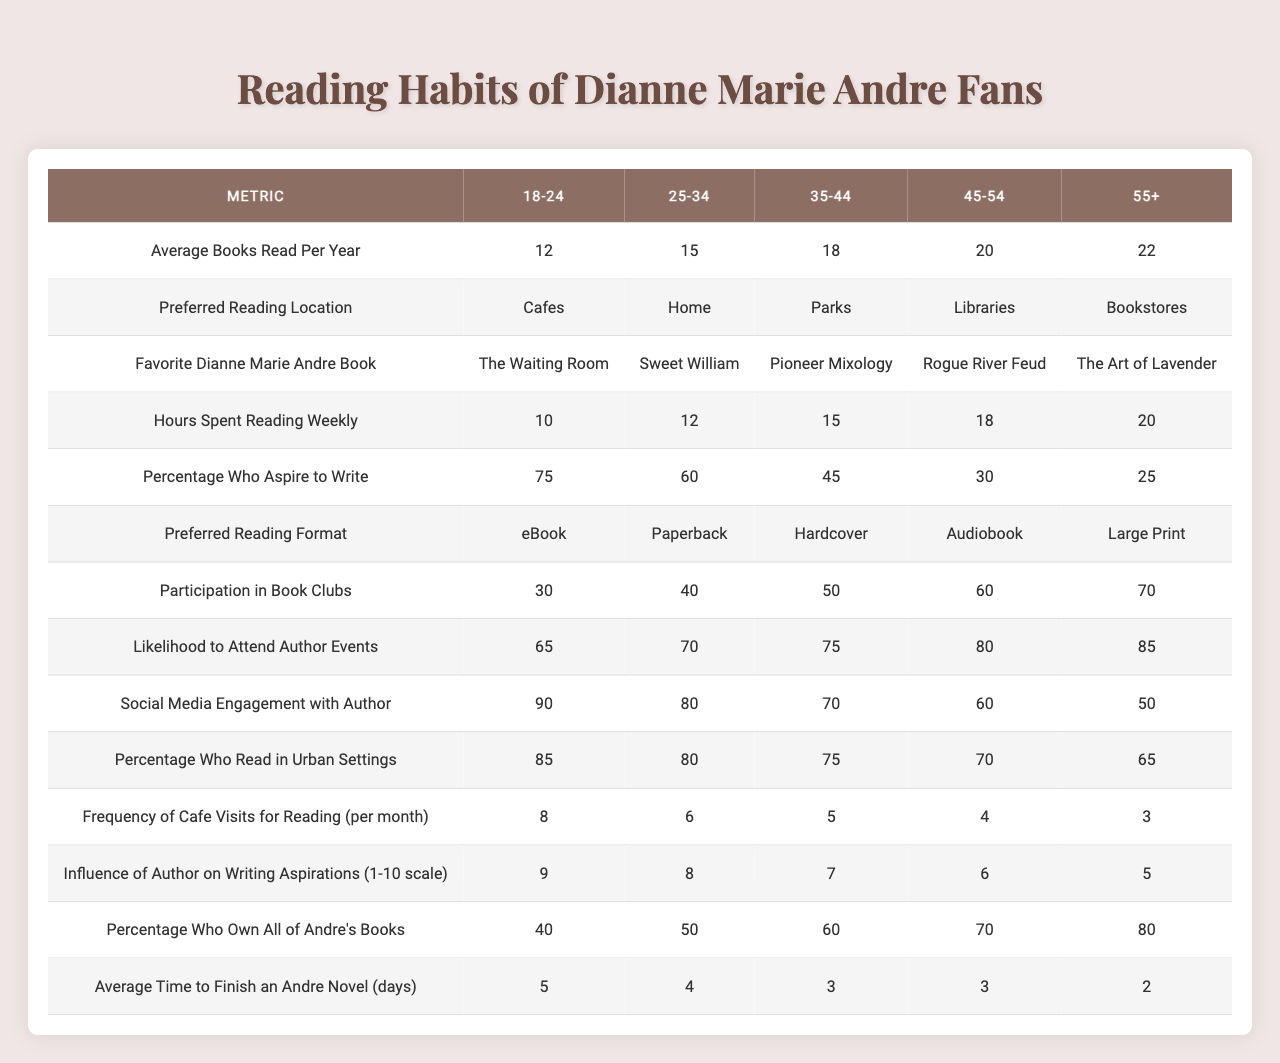What is the average number of books read per year by the 18-24 age group? The table shows the "Average Books Read Per Year" for the 18-24 age group, which is listed as 12.
Answer: 12 Which age group has the highest percentage of fans who aspire to write? Looking at the "Percentage Who Aspire to Write" column, the 18-24 age group has the highest percentage at 75%.
Answer: 75% What is the preferred reading location for the 35-44 age group? The table indicates that the "Preferred Reading Location" for the 35-44 age group is "Parks."
Answer: Parks How does the average time to finish an Andre novel change from the 25-34 age group to the 55+ age group? For the 25-34 age group, the average time is 4 days, and for the 55+ age group, it is 2 days. The difference is 4 - 2 = 2 days, indicating a decrease in time with increasing age.
Answer: Decrease of 2 days What is the relationship between reading format preference and average books read per year for the 45-54 age group? The "Preferred Reading Format" for the 45-54 age group is "Audiobook," and they read an average of 20 books per year. This suggests a preference for listening while maintaining a high reading volume.
Answer: Audiobook, 20 books Is it true that a higher age group tends to own more of Dianne Marie Andre's books? Yes, by comparing the "Percentage Who Own All of Andre's Books," it shows increasing ownership from 40% for 18-24 to 80% for 55+ age groups, confirming this trend.
Answer: Yes What is the likelihood to attend author events for the 25-34 age group compared to the 55+ age group? The likelihood to attend author events for 25-34 age group is 70%, while for 55+ age group it is 85%. This shows that older fans are more likely to attend events than younger fans, a difference of 15 percentage points.
Answer: 15 percentage points How many total hours per week do fans in the 45-54 age group spend reading? The table states that the "Hours Spent Reading Weekly" for the 45-54 age group is 18 hours.
Answer: 18 hours If we look at cafe visits for reading, which age group visits more often per month? According to the "Frequency of Cafe Visits for Reading (per month)," the 18-24 age group visits 8 times, which is the most frequent among the age groups.
Answer: 8 times What is the average number of hours spent reading weekly across all age groups? To find the average, we sum hours (10 + 12 + 15 + 18 + 20 = 75) and divide by 5 (75 / 5 = 15).
Answer: 15 hours In what way does social media engagement with the author differ between the youngest and oldest age groups? The "Social Media Engagement with Author" shows 90% for the 18-24 age group and 50% for the 55+ age group, indicating a decline of 40% in engagement as age increases.
Answer: 40% decline 